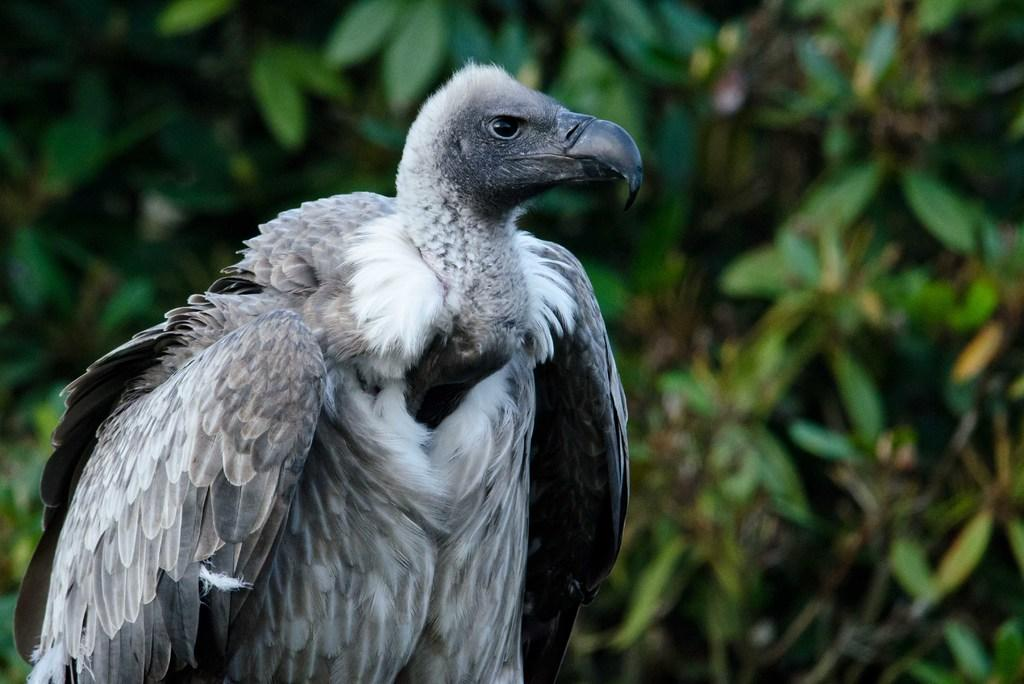What type of bird is in the image? There is a vulture in the image. On which side of the image is the vulture located? The vulture is on the left side of the image. What can be seen in the background of the image? There are green leaves in the background of the image. What type of church can be seen in the background of the image? There is no church present in the image; it features a vulture and green leaves in the background. Can you tell me how many chickens are visible in the image? There are no chickens present in the image; it features a vulture and green leaves in the background. 